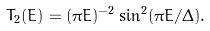Convert formula to latex. <formula><loc_0><loc_0><loc_500><loc_500>T _ { 2 } ( E ) = ( \pi E ) ^ { - 2 } \sin ^ { 2 } ( \pi E / { \mathit \Delta } ) .</formula> 